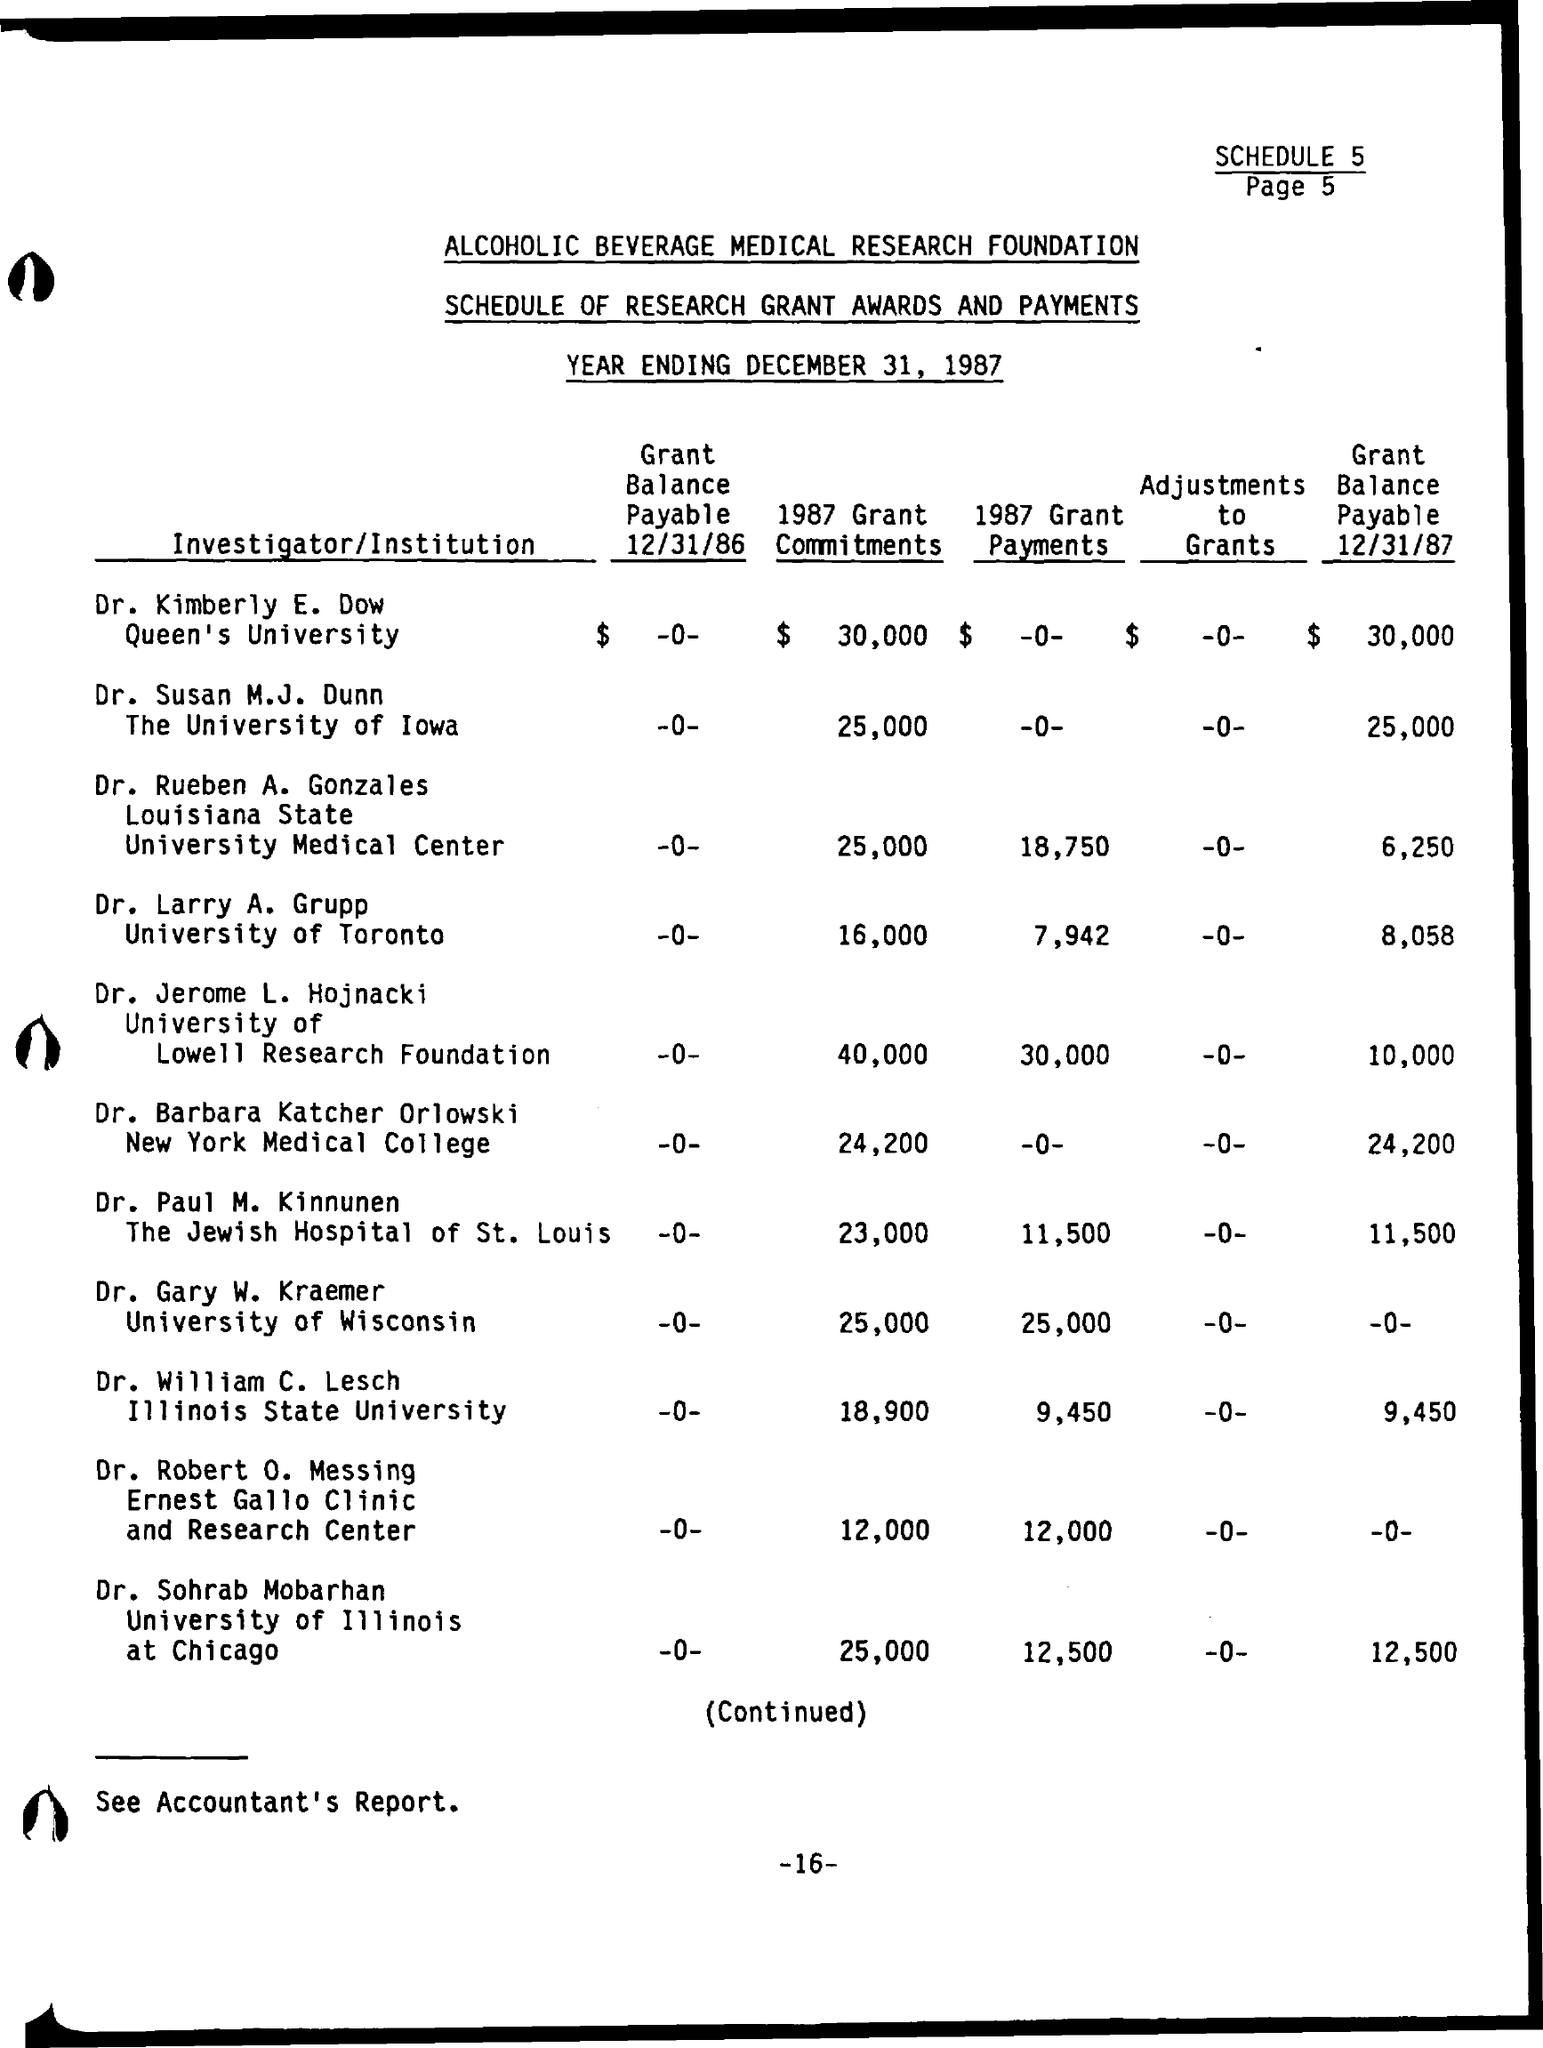What is the Year Ending?
Give a very brief answer. December 31, 1987. What is the Grant Balance Payable 12/31/87 by Dr. Kimberly E. Dow?
Provide a short and direct response. $ 30,000. 